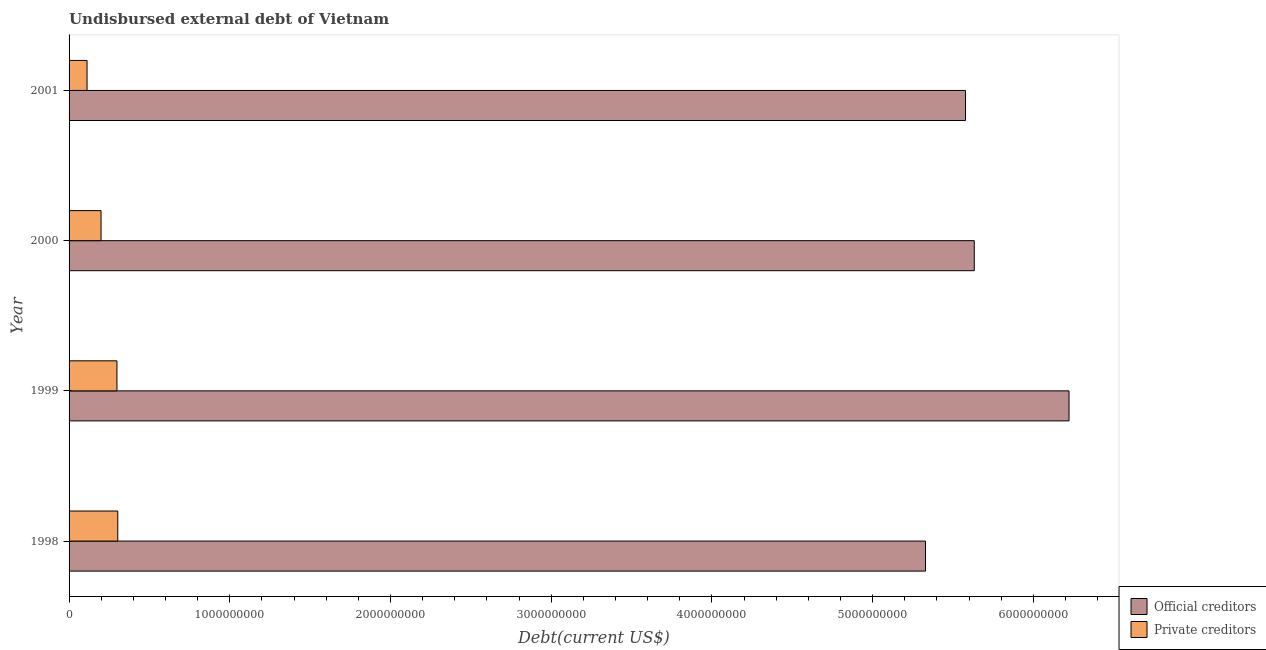How many different coloured bars are there?
Provide a succinct answer. 2. How many groups of bars are there?
Offer a very short reply. 4. How many bars are there on the 1st tick from the bottom?
Your answer should be very brief. 2. What is the label of the 4th group of bars from the top?
Your answer should be compact. 1998. What is the undisbursed external debt of official creditors in 2000?
Your answer should be very brief. 5.63e+09. Across all years, what is the maximum undisbursed external debt of private creditors?
Make the answer very short. 3.03e+08. Across all years, what is the minimum undisbursed external debt of private creditors?
Keep it short and to the point. 1.12e+08. In which year was the undisbursed external debt of official creditors maximum?
Provide a short and direct response. 1999. In which year was the undisbursed external debt of private creditors minimum?
Your answer should be very brief. 2001. What is the total undisbursed external debt of official creditors in the graph?
Make the answer very short. 2.28e+1. What is the difference between the undisbursed external debt of private creditors in 1998 and that in 2001?
Your response must be concise. 1.91e+08. What is the difference between the undisbursed external debt of official creditors in 1999 and the undisbursed external debt of private creditors in 2001?
Keep it short and to the point. 6.11e+09. What is the average undisbursed external debt of official creditors per year?
Your answer should be compact. 5.69e+09. In the year 1998, what is the difference between the undisbursed external debt of private creditors and undisbursed external debt of official creditors?
Your response must be concise. -5.03e+09. In how many years, is the undisbursed external debt of official creditors greater than 5200000000 US$?
Keep it short and to the point. 4. What is the ratio of the undisbursed external debt of private creditors in 1998 to that in 2001?
Your response must be concise. 2.71. What is the difference between the highest and the second highest undisbursed external debt of official creditors?
Ensure brevity in your answer.  5.90e+08. What is the difference between the highest and the lowest undisbursed external debt of official creditors?
Offer a very short reply. 8.93e+08. What does the 2nd bar from the top in 1999 represents?
Give a very brief answer. Official creditors. What does the 2nd bar from the bottom in 2000 represents?
Give a very brief answer. Private creditors. How many bars are there?
Offer a very short reply. 8. Are all the bars in the graph horizontal?
Provide a short and direct response. Yes. How many years are there in the graph?
Give a very brief answer. 4. What is the difference between two consecutive major ticks on the X-axis?
Provide a succinct answer. 1.00e+09. Where does the legend appear in the graph?
Your answer should be very brief. Bottom right. How are the legend labels stacked?
Your answer should be very brief. Vertical. What is the title of the graph?
Your response must be concise. Undisbursed external debt of Vietnam. What is the label or title of the X-axis?
Keep it short and to the point. Debt(current US$). What is the Debt(current US$) in Official creditors in 1998?
Keep it short and to the point. 5.33e+09. What is the Debt(current US$) of Private creditors in 1998?
Offer a terse response. 3.03e+08. What is the Debt(current US$) in Official creditors in 1999?
Your answer should be compact. 6.22e+09. What is the Debt(current US$) of Private creditors in 1999?
Provide a short and direct response. 2.98e+08. What is the Debt(current US$) of Official creditors in 2000?
Give a very brief answer. 5.63e+09. What is the Debt(current US$) of Private creditors in 2000?
Your response must be concise. 1.99e+08. What is the Debt(current US$) of Official creditors in 2001?
Keep it short and to the point. 5.58e+09. What is the Debt(current US$) of Private creditors in 2001?
Offer a terse response. 1.12e+08. Across all years, what is the maximum Debt(current US$) of Official creditors?
Offer a terse response. 6.22e+09. Across all years, what is the maximum Debt(current US$) of Private creditors?
Keep it short and to the point. 3.03e+08. Across all years, what is the minimum Debt(current US$) of Official creditors?
Make the answer very short. 5.33e+09. Across all years, what is the minimum Debt(current US$) of Private creditors?
Provide a short and direct response. 1.12e+08. What is the total Debt(current US$) of Official creditors in the graph?
Give a very brief answer. 2.28e+1. What is the total Debt(current US$) in Private creditors in the graph?
Keep it short and to the point. 9.12e+08. What is the difference between the Debt(current US$) of Official creditors in 1998 and that in 1999?
Offer a very short reply. -8.93e+08. What is the difference between the Debt(current US$) of Private creditors in 1998 and that in 1999?
Your answer should be very brief. 5.08e+06. What is the difference between the Debt(current US$) in Official creditors in 1998 and that in 2000?
Provide a succinct answer. -3.03e+08. What is the difference between the Debt(current US$) in Private creditors in 1998 and that in 2000?
Keep it short and to the point. 1.04e+08. What is the difference between the Debt(current US$) of Official creditors in 1998 and that in 2001?
Your answer should be very brief. -2.49e+08. What is the difference between the Debt(current US$) of Private creditors in 1998 and that in 2001?
Provide a short and direct response. 1.91e+08. What is the difference between the Debt(current US$) of Official creditors in 1999 and that in 2000?
Your response must be concise. 5.90e+08. What is the difference between the Debt(current US$) in Private creditors in 1999 and that in 2000?
Give a very brief answer. 9.90e+07. What is the difference between the Debt(current US$) of Official creditors in 1999 and that in 2001?
Make the answer very short. 6.44e+08. What is the difference between the Debt(current US$) of Private creditors in 1999 and that in 2001?
Your answer should be compact. 1.86e+08. What is the difference between the Debt(current US$) in Official creditors in 2000 and that in 2001?
Offer a very short reply. 5.46e+07. What is the difference between the Debt(current US$) of Private creditors in 2000 and that in 2001?
Give a very brief answer. 8.71e+07. What is the difference between the Debt(current US$) in Official creditors in 1998 and the Debt(current US$) in Private creditors in 1999?
Offer a very short reply. 5.03e+09. What is the difference between the Debt(current US$) of Official creditors in 1998 and the Debt(current US$) of Private creditors in 2000?
Offer a terse response. 5.13e+09. What is the difference between the Debt(current US$) of Official creditors in 1998 and the Debt(current US$) of Private creditors in 2001?
Your answer should be compact. 5.22e+09. What is the difference between the Debt(current US$) of Official creditors in 1999 and the Debt(current US$) of Private creditors in 2000?
Your response must be concise. 6.02e+09. What is the difference between the Debt(current US$) in Official creditors in 1999 and the Debt(current US$) in Private creditors in 2001?
Your response must be concise. 6.11e+09. What is the difference between the Debt(current US$) in Official creditors in 2000 and the Debt(current US$) in Private creditors in 2001?
Give a very brief answer. 5.52e+09. What is the average Debt(current US$) of Official creditors per year?
Make the answer very short. 5.69e+09. What is the average Debt(current US$) in Private creditors per year?
Ensure brevity in your answer.  2.28e+08. In the year 1998, what is the difference between the Debt(current US$) of Official creditors and Debt(current US$) of Private creditors?
Offer a very short reply. 5.03e+09. In the year 1999, what is the difference between the Debt(current US$) of Official creditors and Debt(current US$) of Private creditors?
Offer a terse response. 5.92e+09. In the year 2000, what is the difference between the Debt(current US$) of Official creditors and Debt(current US$) of Private creditors?
Ensure brevity in your answer.  5.43e+09. In the year 2001, what is the difference between the Debt(current US$) in Official creditors and Debt(current US$) in Private creditors?
Provide a succinct answer. 5.47e+09. What is the ratio of the Debt(current US$) in Official creditors in 1998 to that in 1999?
Offer a very short reply. 0.86. What is the ratio of the Debt(current US$) of Private creditors in 1998 to that in 1999?
Keep it short and to the point. 1.02. What is the ratio of the Debt(current US$) in Official creditors in 1998 to that in 2000?
Give a very brief answer. 0.95. What is the ratio of the Debt(current US$) of Private creditors in 1998 to that in 2000?
Your answer should be very brief. 1.52. What is the ratio of the Debt(current US$) of Official creditors in 1998 to that in 2001?
Provide a succinct answer. 0.96. What is the ratio of the Debt(current US$) of Private creditors in 1998 to that in 2001?
Ensure brevity in your answer.  2.71. What is the ratio of the Debt(current US$) of Official creditors in 1999 to that in 2000?
Your answer should be very brief. 1.1. What is the ratio of the Debt(current US$) of Private creditors in 1999 to that in 2000?
Provide a succinct answer. 1.5. What is the ratio of the Debt(current US$) of Official creditors in 1999 to that in 2001?
Make the answer very short. 1.12. What is the ratio of the Debt(current US$) of Private creditors in 1999 to that in 2001?
Provide a succinct answer. 2.66. What is the ratio of the Debt(current US$) in Official creditors in 2000 to that in 2001?
Provide a succinct answer. 1.01. What is the ratio of the Debt(current US$) of Private creditors in 2000 to that in 2001?
Make the answer very short. 1.78. What is the difference between the highest and the second highest Debt(current US$) of Official creditors?
Make the answer very short. 5.90e+08. What is the difference between the highest and the second highest Debt(current US$) of Private creditors?
Your answer should be very brief. 5.08e+06. What is the difference between the highest and the lowest Debt(current US$) in Official creditors?
Offer a terse response. 8.93e+08. What is the difference between the highest and the lowest Debt(current US$) in Private creditors?
Ensure brevity in your answer.  1.91e+08. 